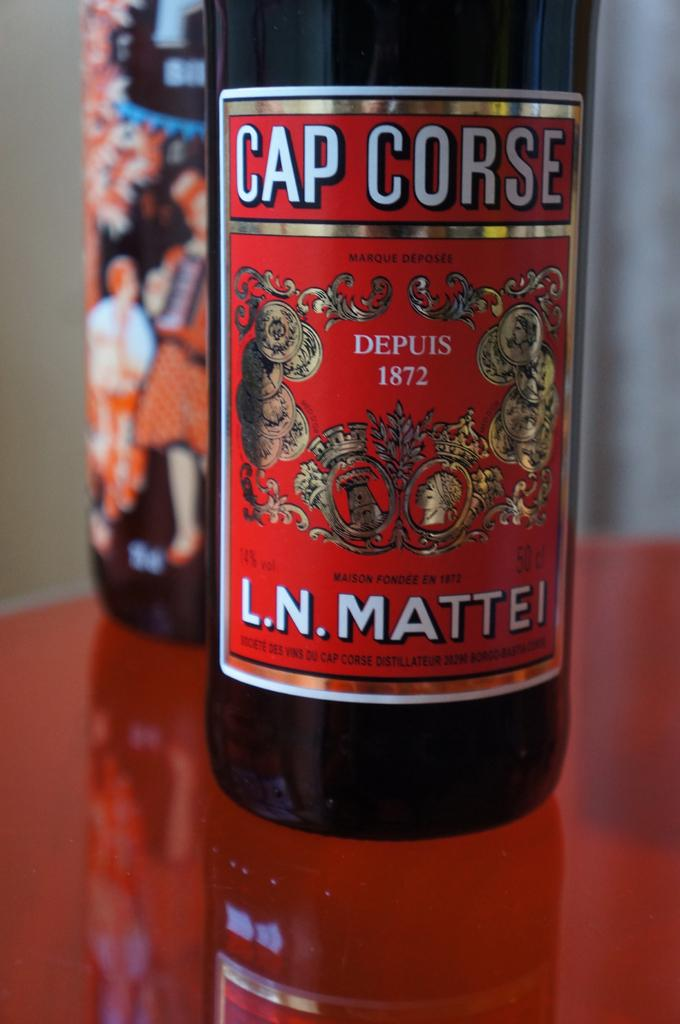Provide a one-sentence caption for the provided image. a bottle of CAP CORSE L.N. MATTEI LIQUOR. 